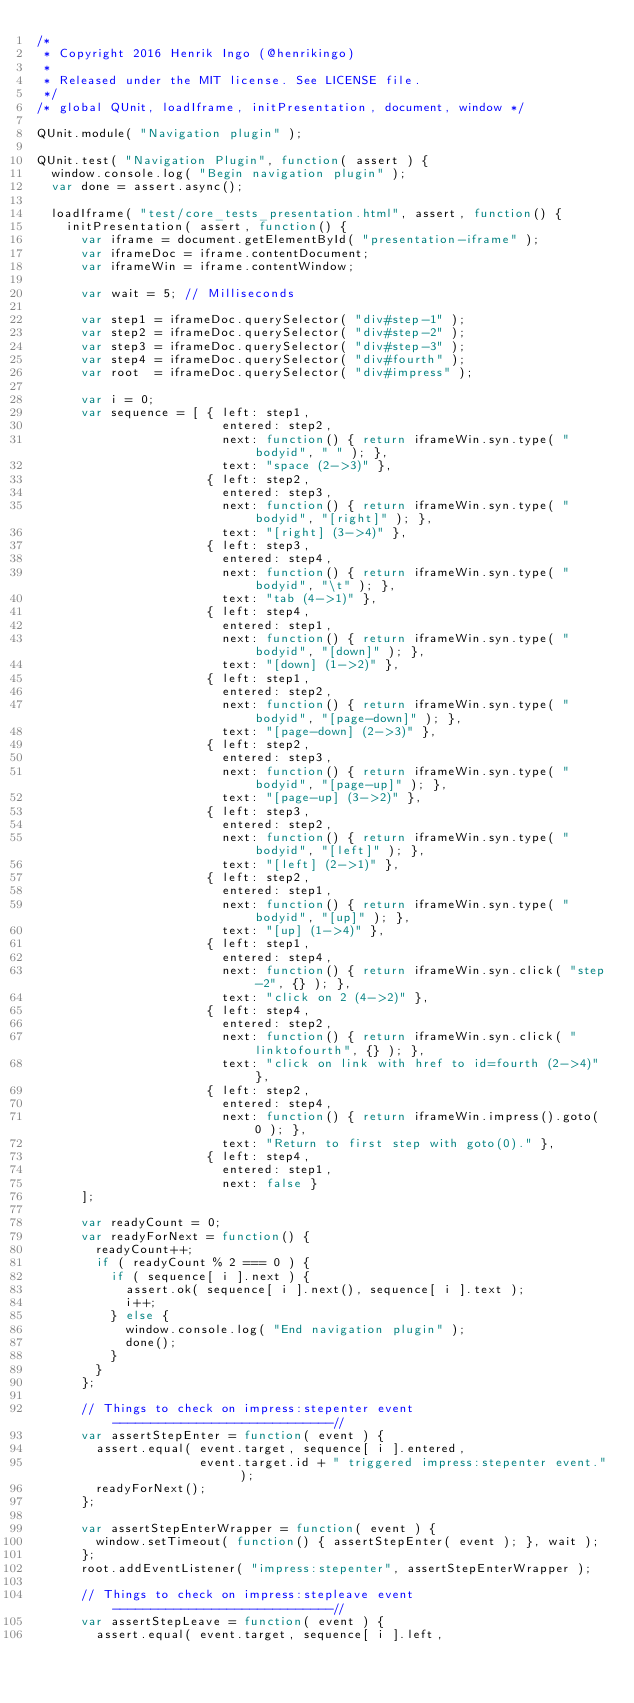Convert code to text. <code><loc_0><loc_0><loc_500><loc_500><_JavaScript_>/*
 * Copyright 2016 Henrik Ingo (@henrikingo)
 *
 * Released under the MIT license. See LICENSE file.
 */
/* global QUnit, loadIframe, initPresentation, document, window */

QUnit.module( "Navigation plugin" );

QUnit.test( "Navigation Plugin", function( assert ) {
  window.console.log( "Begin navigation plugin" );
  var done = assert.async();

  loadIframe( "test/core_tests_presentation.html", assert, function() {
    initPresentation( assert, function() {
      var iframe = document.getElementById( "presentation-iframe" );
      var iframeDoc = iframe.contentDocument;
      var iframeWin = iframe.contentWindow;

      var wait = 5; // Milliseconds

      var step1 = iframeDoc.querySelector( "div#step-1" );
      var step2 = iframeDoc.querySelector( "div#step-2" );
      var step3 = iframeDoc.querySelector( "div#step-3" );
      var step4 = iframeDoc.querySelector( "div#fourth" );
      var root  = iframeDoc.querySelector( "div#impress" );

      var i = 0;
      var sequence = [ { left: step1,
                         entered: step2,
                         next: function() { return iframeWin.syn.type( "bodyid", " " ); },
                         text: "space (2->3)" },
                       { left: step2,
                         entered: step3,
                         next: function() { return iframeWin.syn.type( "bodyid", "[right]" ); },
                         text: "[right] (3->4)" },
                       { left: step3,
                         entered: step4,
                         next: function() { return iframeWin.syn.type( "bodyid", "\t" ); },
                         text: "tab (4->1)" },
                       { left: step4,
                         entered: step1,
                         next: function() { return iframeWin.syn.type( "bodyid", "[down]" ); },
                         text: "[down] (1->2)" },
                       { left: step1,
                         entered: step2,
                         next: function() { return iframeWin.syn.type( "bodyid", "[page-down]" ); },
                         text: "[page-down] (2->3)" },
                       { left: step2,
                         entered: step3,
                         next: function() { return iframeWin.syn.type( "bodyid", "[page-up]" ); },
                         text: "[page-up] (3->2)" },
                       { left: step3,
                         entered: step2,
                         next: function() { return iframeWin.syn.type( "bodyid", "[left]" ); },
                         text: "[left] (2->1)" },
                       { left: step2,
                         entered: step1,
                         next: function() { return iframeWin.syn.type( "bodyid", "[up]" ); },
                         text: "[up] (1->4)" },
                       { left: step1,
                         entered: step4,
                         next: function() { return iframeWin.syn.click( "step-2", {} ); },
                         text: "click on 2 (4->2)" },
                       { left: step4,
                         entered: step2,
                         next: function() { return iframeWin.syn.click( "linktofourth", {} ); },
                         text: "click on link with href to id=fourth (2->4)" },
                       { left: step2,
                         entered: step4,
                         next: function() { return iframeWin.impress().goto( 0 ); },
                         text: "Return to first step with goto(0)." },
                       { left: step4,
                         entered: step1,
                         next: false }
      ];

      var readyCount = 0;
      var readyForNext = function() {
        readyCount++;
        if ( readyCount % 2 === 0 ) {
          if ( sequence[ i ].next ) {
            assert.ok( sequence[ i ].next(), sequence[ i ].text );
            i++;
          } else {
            window.console.log( "End navigation plugin" );
            done();
          }
        }
      };

      // Things to check on impress:stepenter event -----------------------------//
      var assertStepEnter = function( event ) {
        assert.equal( event.target, sequence[ i ].entered,
                      event.target.id + " triggered impress:stepenter event." );
        readyForNext();
      };

      var assertStepEnterWrapper = function( event ) {
        window.setTimeout( function() { assertStepEnter( event ); }, wait );
      };
      root.addEventListener( "impress:stepenter", assertStepEnterWrapper );

      // Things to check on impress:stepleave event -----------------------------//
      var assertStepLeave = function( event ) {
        assert.equal( event.target, sequence[ i ].left,</code> 